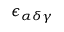<formula> <loc_0><loc_0><loc_500><loc_500>\epsilon _ { \alpha \delta \gamma }</formula> 